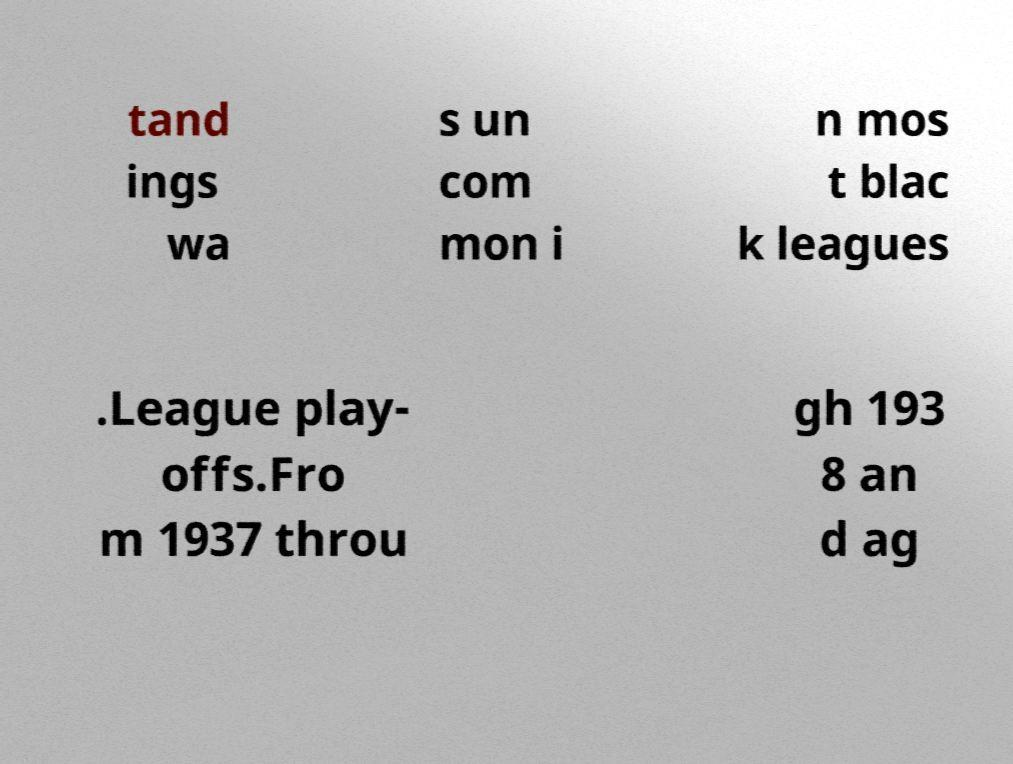Could you extract and type out the text from this image? tand ings wa s un com mon i n mos t blac k leagues .League play- offs.Fro m 1937 throu gh 193 8 an d ag 